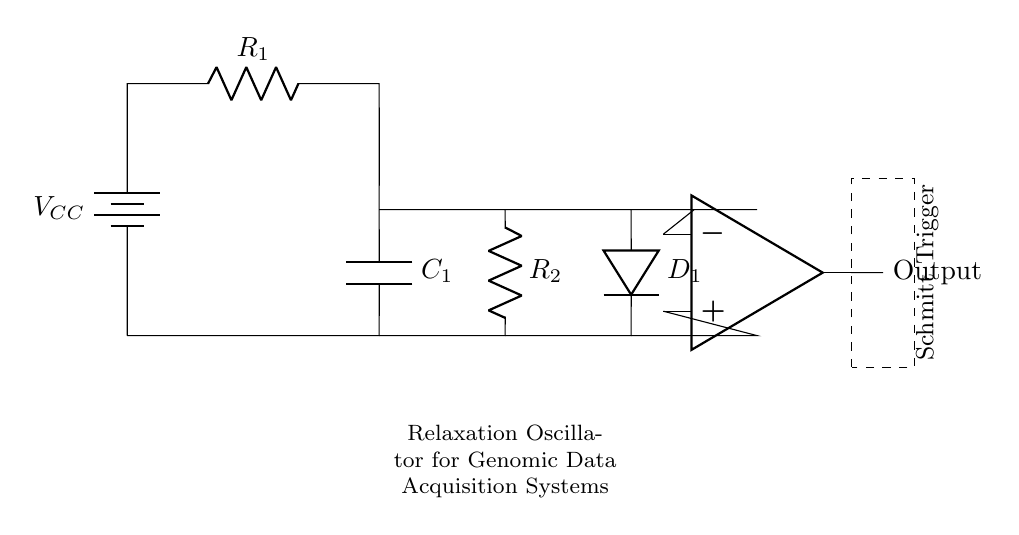What is the function of the op-amp in this circuit? The op-amp acts as a Schmitt Trigger, which helps in generating a square wave output with controlled thresholds. It utilizes hysteresis to provide a clean transitioning output signal for the oscillation.
Answer: Schmitt Trigger What type of capacitor is used in the circuit? The circuit contains a capacitor labeled as C1, which functions to store charge and determines the timing characteristics of the oscillator.
Answer: Capacitor What is the purpose of resistor R1? Resistor R1 is used to limit the current flowing into the capacitor C1, thus controlling the charge and discharge time, which is crucial for oscillation frequency.
Answer: Current limiting How does the circuit generate periodic interrupts? The relaxation oscillator generates periodic interrupts by charging and discharging the capacitor, which produces a square wave output from the op-amp Schmitt Trigger that can be used effectively for timing in data acquisition.
Answer: Square wave output What component provides the voltage supply for this circuit? The circuit is powered by a battery indicated by V_CC, which supplies the necessary voltage for all components to function properly.
Answer: Battery What does the dashed rectangle represent in the circuit? The dashed rectangle symbolizes the area where the Schmitt Trigger op-amp is located, indicating that it's enclosed as a separate functional block for clarity in the diagram.
Answer: Schmitt Trigger 